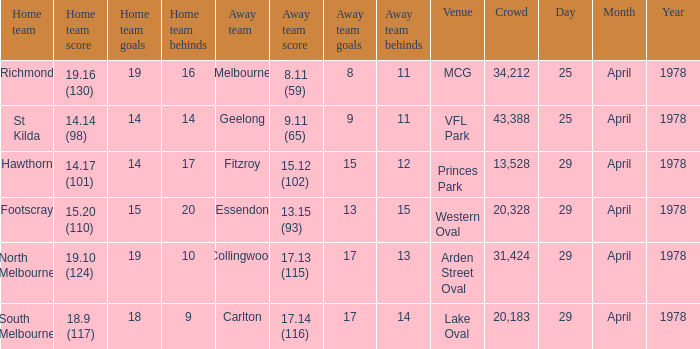What was the away team that played at Princes Park? Fitzroy. 